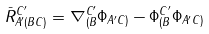<formula> <loc_0><loc_0><loc_500><loc_500>\bar { R } _ { A ^ { \prime } ( B C ) } ^ { C ^ { \prime } } = \nabla _ { ( B } ^ { C ^ { \prime } } \Phi _ { A ^ { \prime } C ) } - \Phi _ { ( B } ^ { C ^ { \prime } } \Phi _ { A ^ { \prime } C ) }</formula> 